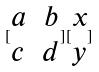Convert formula to latex. <formula><loc_0><loc_0><loc_500><loc_500>[ \begin{matrix} a & b \\ c & d \end{matrix} ] [ \begin{matrix} x \\ y \end{matrix} ]</formula> 